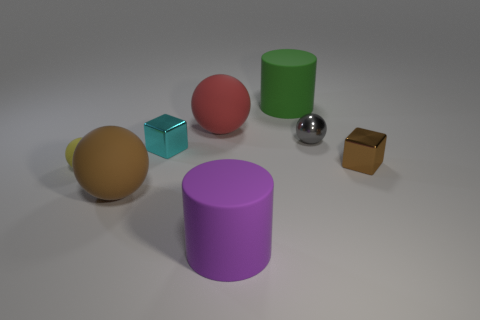There is a metallic block that is on the right side of the cyan metal object; is it the same color as the large matte cylinder that is in front of the cyan metallic thing?
Give a very brief answer. No. There is a metal block that is in front of the cyan shiny cube; are there any cyan metallic objects in front of it?
Offer a terse response. No. Is the number of tiny objects to the left of the big green cylinder less than the number of tiny objects in front of the big red sphere?
Make the answer very short. Yes. Do the large sphere that is behind the yellow rubber ball and the cyan thing that is left of the large purple matte cylinder have the same material?
Provide a short and direct response. No. How many big objects are either purple matte objects or cubes?
Your answer should be very brief. 1. There is a small cyan object that is the same material as the gray thing; what is its shape?
Keep it short and to the point. Cube. Is the number of spheres that are in front of the gray object less than the number of things?
Keep it short and to the point. Yes. Is the shape of the small brown thing the same as the cyan thing?
Your answer should be compact. Yes. What number of metal things are small things or small spheres?
Give a very brief answer. 3. Is there a matte thing of the same size as the cyan block?
Keep it short and to the point. Yes. 